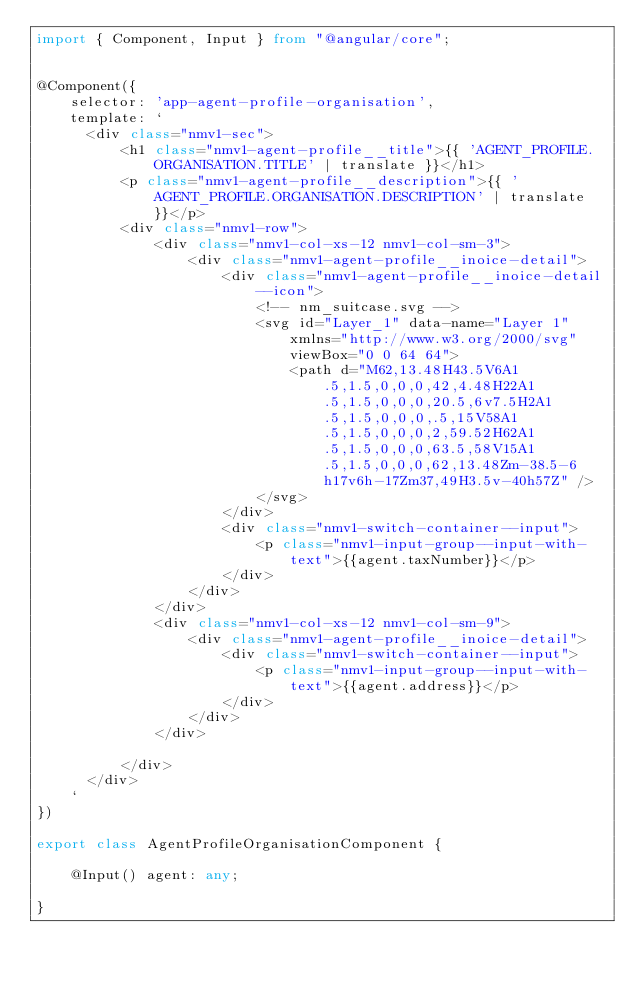<code> <loc_0><loc_0><loc_500><loc_500><_TypeScript_>import { Component, Input } from "@angular/core";


@Component({
	selector: 'app-agent-profile-organisation',
	template: `
      <div class="nmv1-sec">
          <h1 class="nmv1-agent-profile__title">{{ 'AGENT_PROFILE.ORGANISATION.TITLE' | translate }}</h1>
          <p class="nmv1-agent-profile__description">{{ 'AGENT_PROFILE.ORGANISATION.DESCRIPTION' | translate }}</p>
          <div class="nmv1-row">
              <div class="nmv1-col-xs-12 nmv1-col-sm-3">
                  <div class="nmv1-agent-profile__inoice-detail">
                      <div class="nmv1-agent-profile__inoice-detail--icon">
                          <!-- nm_suitcase.svg -->
                          <svg id="Layer_1" data-name="Layer 1" xmlns="http://www.w3.org/2000/svg" viewBox="0 0 64 64">
                              <path d="M62,13.48H43.5V6A1.5,1.5,0,0,0,42,4.48H22A1.5,1.5,0,0,0,20.5,6v7.5H2A1.5,1.5,0,0,0,.5,15V58A1.5,1.5,0,0,0,2,59.52H62A1.5,1.5,0,0,0,63.5,58V15A1.5,1.5,0,0,0,62,13.48Zm-38.5-6h17v6h-17Zm37,49H3.5v-40h57Z" />
                          </svg>
                      </div>
                      <div class="nmv1-switch-container--input">
                          <p class="nmv1-input-group--input-with-text">{{agent.taxNumber}}</p>
                      </div>
                  </div>
              </div>
              <div class="nmv1-col-xs-12 nmv1-col-sm-9">
                  <div class="nmv1-agent-profile__inoice-detail">
                      <div class="nmv1-switch-container--input">
                          <p class="nmv1-input-group--input-with-text">{{agent.address}}</p>
                      </div>
                  </div>
              </div>

          </div>
      </div>
	`
})

export class AgentProfileOrganisationComponent {

	@Input() agent: any;

}</code> 